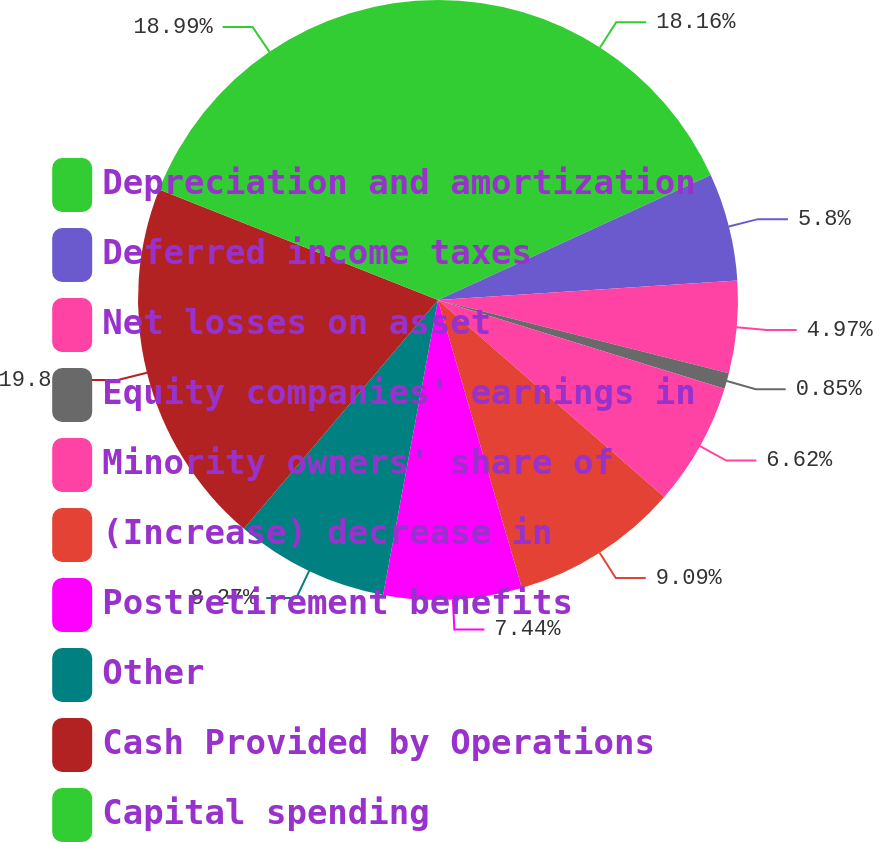Convert chart to OTSL. <chart><loc_0><loc_0><loc_500><loc_500><pie_chart><fcel>Depreciation and amortization<fcel>Deferred income taxes<fcel>Net losses on asset<fcel>Equity companies' earnings in<fcel>Minority owners' share of<fcel>(Increase) decrease in<fcel>Postretirement benefits<fcel>Other<fcel>Cash Provided by Operations<fcel>Capital spending<nl><fcel>18.16%<fcel>5.8%<fcel>4.97%<fcel>0.85%<fcel>6.62%<fcel>9.09%<fcel>7.44%<fcel>8.27%<fcel>19.81%<fcel>18.99%<nl></chart> 